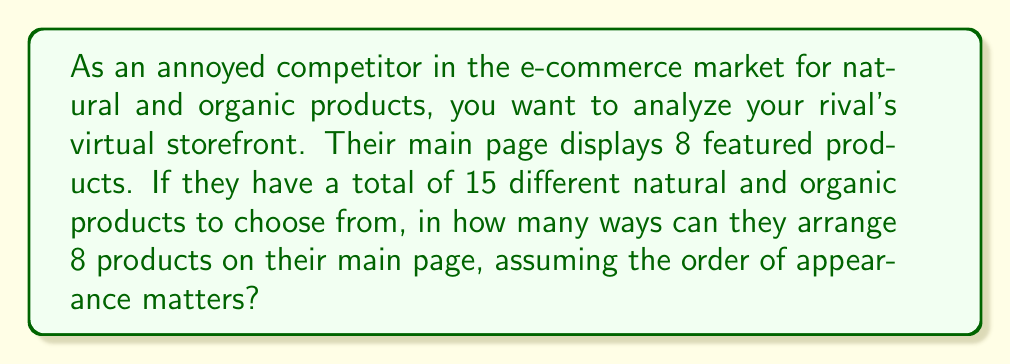Could you help me with this problem? To solve this problem, we need to use the concept of permutations. We are selecting 8 products out of 15 and arranging them in a specific order. This is a permutation without repetition, as each product can only be used once.

The formula for permutations without repetition is:

$$P(n,r) = \frac{n!}{(n-r)!}$$

Where:
$n$ = total number of items to choose from
$r$ = number of items being arranged

In this case:
$n = 15$ (total number of products)
$r = 8$ (number of products displayed on the main page)

Plugging these values into the formula:

$$P(15,8) = \frac{15!}{(15-8)!} = \frac{15!}{7!}$$

Expanding this:

$$\frac{15 \cdot 14 \cdot 13 \cdot 12 \cdot 11 \cdot 10 \cdot 9 \cdot 8 \cdot 7!}{7!}$$

The $7!$ cancels out in the numerator and denominator:

$$15 \cdot 14 \cdot 13 \cdot 12 \cdot 11 \cdot 10 \cdot 9 \cdot 8 = 259,459,200$$

Therefore, there are 259,459,200 ways to arrange 8 products out of 15 on the virtual storefront page.
Answer: 259,459,200 